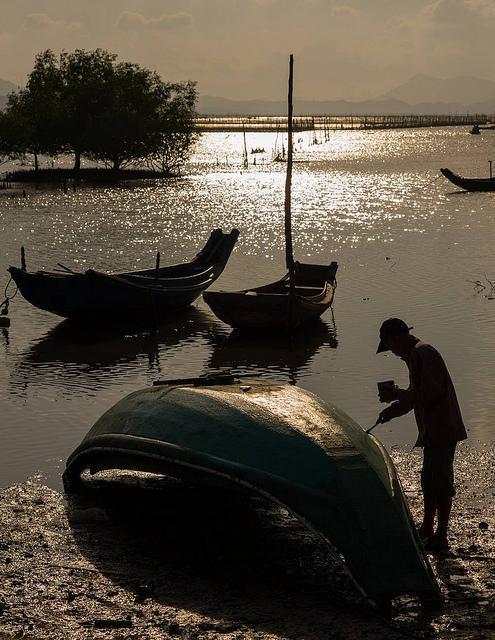What is the goal of the man working on the boat here?
Select the correct answer and articulate reasoning with the following format: 'Answer: answer
Rationale: rationale.'
Options: Waterproofing, decorative, spy craft, weight loss. Answer: waterproofing.
Rationale: He is fixing the boat so there won't be any leaks 